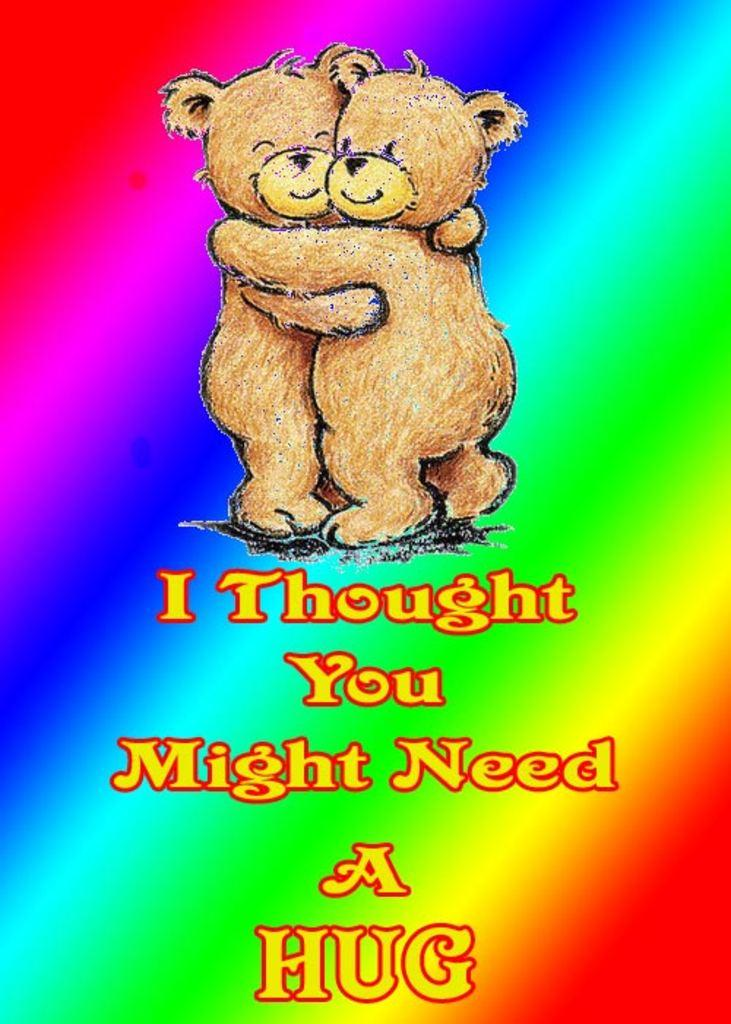What type of image is being described? The image is animated. Are there any words or phrases in the image? Yes, there is text in the image. What kind of characters or objects can be seen in the image? There are teddy bears in the image. How many snails are crawling on the teddy bears in the image? There are no snails present in the image; it only features teddy bears. What type of bird can be seen flying near the teddy bears in the image? There is no bird, specifically a robin, present in the image; it only features teddy bears. 